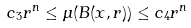Convert formula to latex. <formula><loc_0><loc_0><loc_500><loc_500>c _ { 3 } r ^ { n } \leq \mu ( B ( x , r ) ) \leq c _ { 4 } r ^ { n }</formula> 